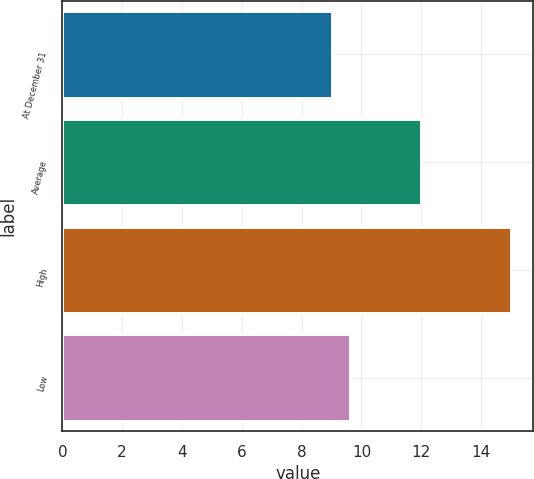Convert chart to OTSL. <chart><loc_0><loc_0><loc_500><loc_500><bar_chart><fcel>At December 31<fcel>Average<fcel>High<fcel>Low<nl><fcel>9<fcel>12<fcel>15<fcel>9.6<nl></chart> 